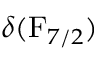<formula> <loc_0><loc_0><loc_500><loc_500>\delta ( F _ { 7 / 2 } )</formula> 